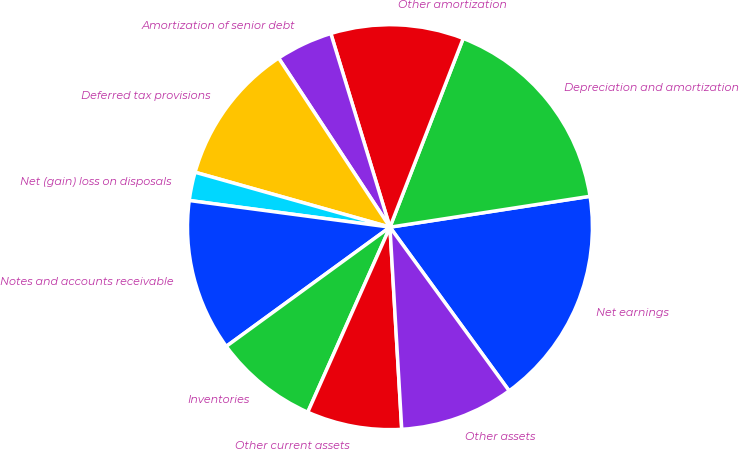Convert chart to OTSL. <chart><loc_0><loc_0><loc_500><loc_500><pie_chart><fcel>Net earnings<fcel>Depreciation and amortization<fcel>Other amortization<fcel>Amortization of senior debt<fcel>Deferred tax provisions<fcel>Net (gain) loss on disposals<fcel>Notes and accounts receivable<fcel>Inventories<fcel>Other current assets<fcel>Other assets<nl><fcel>17.42%<fcel>16.67%<fcel>10.61%<fcel>4.55%<fcel>11.36%<fcel>2.27%<fcel>12.12%<fcel>8.33%<fcel>7.58%<fcel>9.09%<nl></chart> 